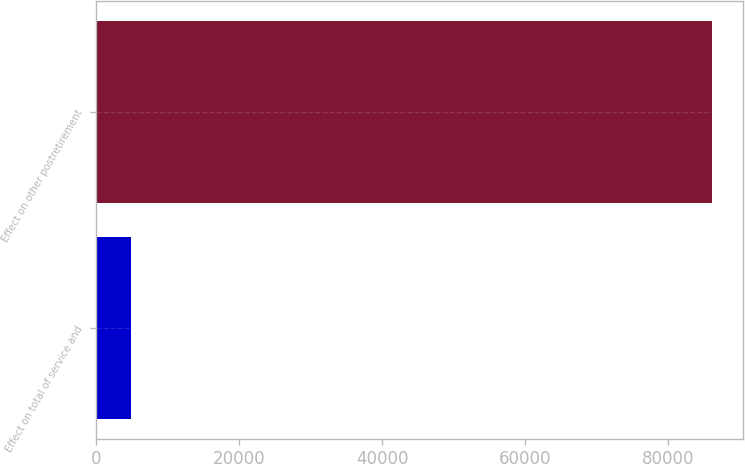Convert chart. <chart><loc_0><loc_0><loc_500><loc_500><bar_chart><fcel>Effect on total of service and<fcel>Effect on other postretirement<nl><fcel>4887<fcel>86179<nl></chart> 